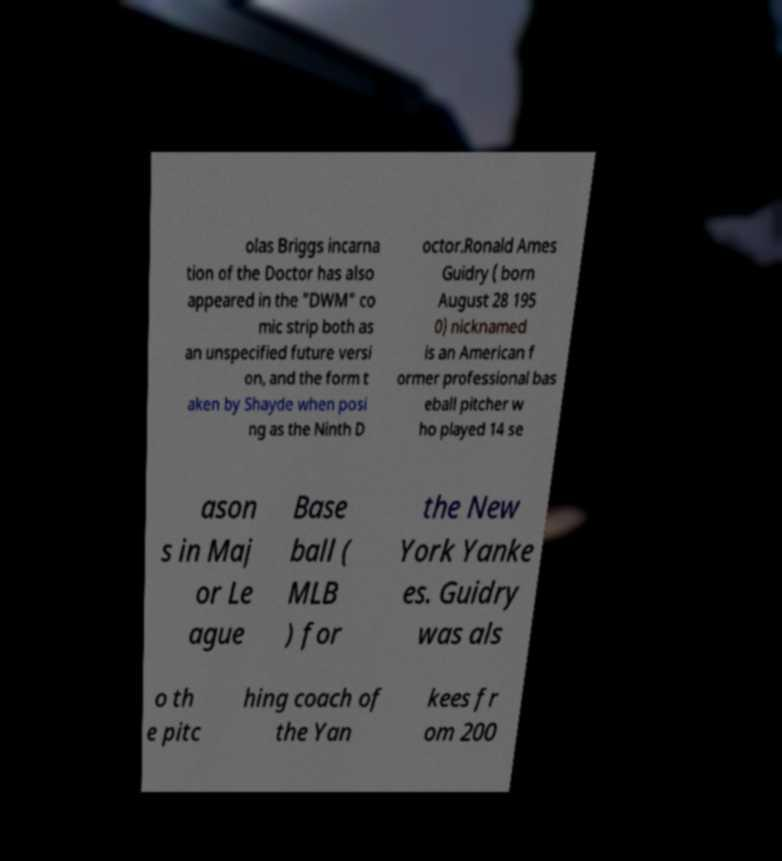For documentation purposes, I need the text within this image transcribed. Could you provide that? olas Briggs incarna tion of the Doctor has also appeared in the "DWM" co mic strip both as an unspecified future versi on, and the form t aken by Shayde when posi ng as the Ninth D octor.Ronald Ames Guidry ( born August 28 195 0) nicknamed is an American f ormer professional bas eball pitcher w ho played 14 se ason s in Maj or Le ague Base ball ( MLB ) for the New York Yanke es. Guidry was als o th e pitc hing coach of the Yan kees fr om 200 